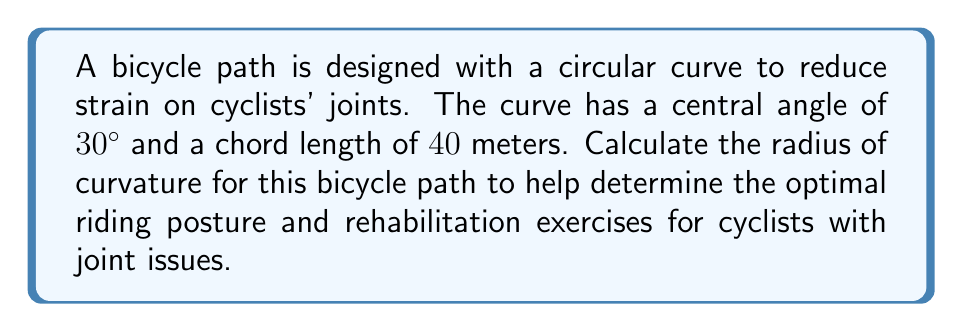Solve this math problem. To find the radius of curvature, we'll use the relationship between the chord length, central angle, and radius of a circle. Let's approach this step-by-step:

1) Let $r$ be the radius of curvature, $c$ be the chord length, and $\theta$ be the central angle in radians.

2) The formula relating these quantities is:

   $$c = 2r \sin(\frac{\theta}{2})$$

3) We're given:
   - Chord length $c = 40$ meters
   - Central angle $\theta = 30°$

4) Convert the angle to radians:
   $$30° = \frac{30 \pi}{180} = \frac{\pi}{6}$$ radians

5) Substitute these values into the formula:

   $$40 = 2r \sin(\frac{\pi}{12})$$

6) Solve for $r$:

   $$r = \frac{40}{2\sin(\frac{\pi}{12})} = \frac{20}{\sin(\frac{\pi}{12})}$$

7) Calculate the value:
   $$r \approx 76.98$$ meters

This radius of curvature allows for a gentle turn, which can help reduce stress on cyclists' joints during the ride.
Answer: $76.98$ meters 